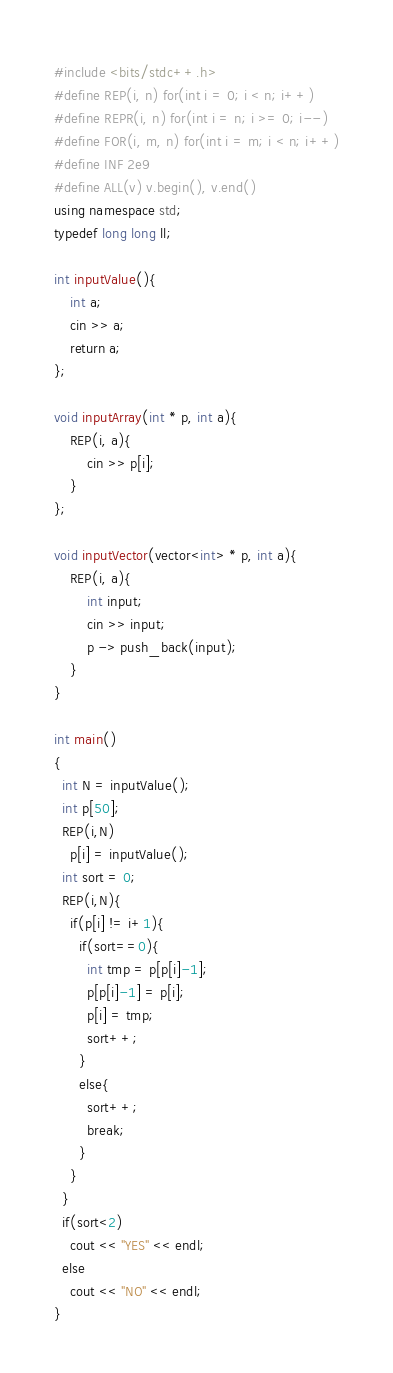Convert code to text. <code><loc_0><loc_0><loc_500><loc_500><_C++_>#include <bits/stdc++.h>
#define REP(i, n) for(int i = 0; i < n; i++)
#define REPR(i, n) for(int i = n; i >= 0; i--)
#define FOR(i, m, n) for(int i = m; i < n; i++)
#define INF 2e9
#define ALL(v) v.begin(), v.end()
using namespace std;
typedef long long ll;

int inputValue(){
    int a;
    cin >> a;
    return a;
};

void inputArray(int * p, int a){
    REP(i, a){
        cin >> p[i];
    }
};

void inputVector(vector<int> * p, int a){
    REP(i, a){
        int input;
        cin >> input;
        p -> push_back(input);
    }
}

int main()
{
  int N = inputValue();
  int p[50];
  REP(i,N)
    p[i] = inputValue();
  int sort = 0;
  REP(i,N){
    if(p[i] != i+1){
      if(sort==0){
        int tmp = p[p[i]-1];
        p[p[i]-1] = p[i];
        p[i] = tmp;
        sort++;
      }
      else{
        sort++;
        break;
      } 
    }
  }
  if(sort<2)
    cout << "YES" << endl;
  else
    cout << "NO" << endl;
}
</code> 